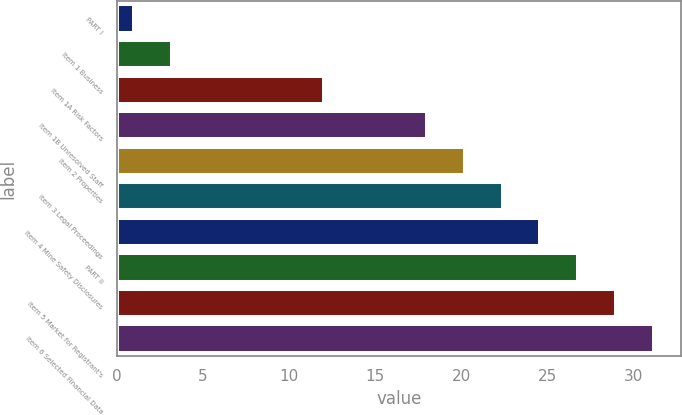Convert chart to OTSL. <chart><loc_0><loc_0><loc_500><loc_500><bar_chart><fcel>PART I<fcel>Item 1 Business<fcel>Item 1A Risk Factors<fcel>Item 1B Unresolved Staff<fcel>Item 2 Properties<fcel>Item 3 Legal Proceedings<fcel>Item 4 Mine Safety Disclosures<fcel>PART II<fcel>Item 5 Market for Registrant's<fcel>Item 6 Selected Financial Data<nl><fcel>1<fcel>3.2<fcel>12<fcel>18<fcel>20.2<fcel>22.4<fcel>24.6<fcel>26.8<fcel>29<fcel>31.2<nl></chart> 